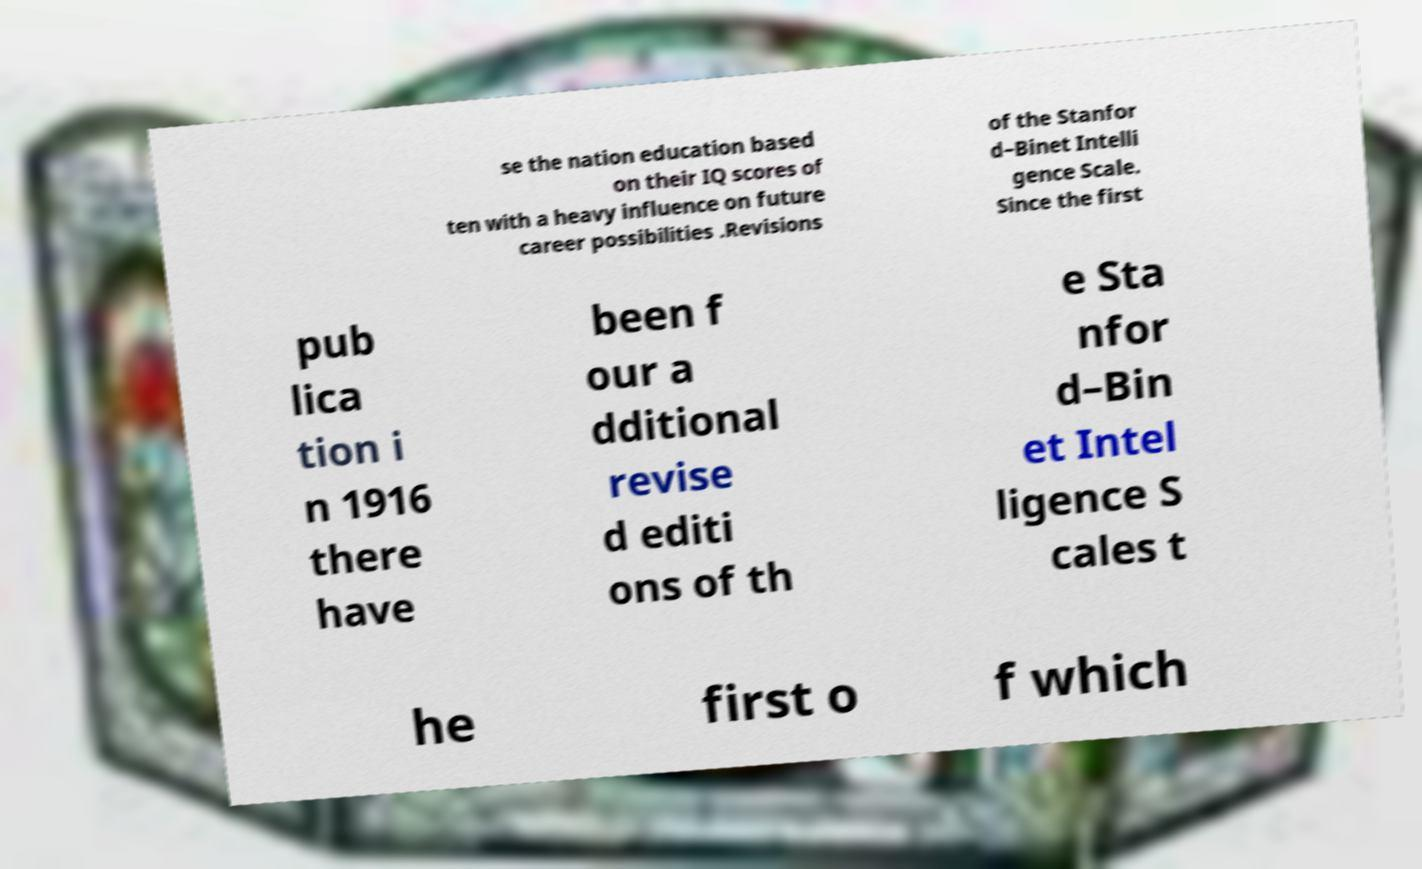Can you read and provide the text displayed in the image?This photo seems to have some interesting text. Can you extract and type it out for me? se the nation education based on their IQ scores of ten with a heavy influence on future career possibilities .Revisions of the Stanfor d–Binet Intelli gence Scale. Since the first pub lica tion i n 1916 there have been f our a dditional revise d editi ons of th e Sta nfor d–Bin et Intel ligence S cales t he first o f which 